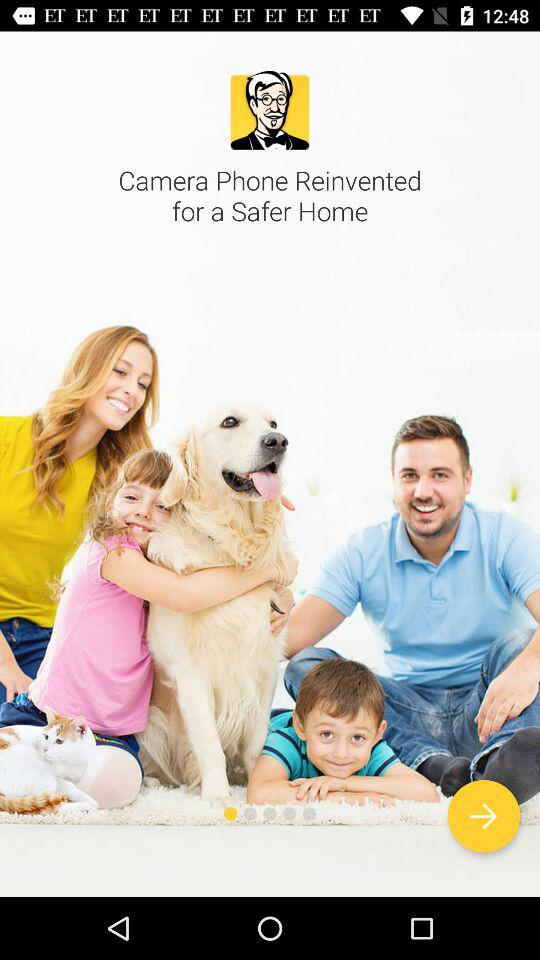What phone is reinvented for a safer home? For a safer home, the camera phone is reinvented. 